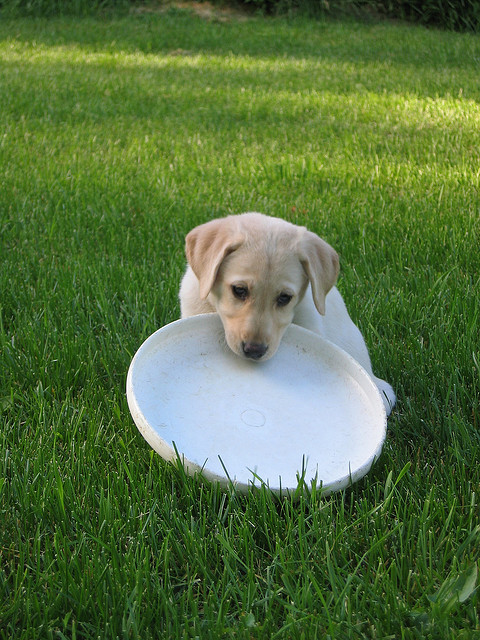What is happening in this image? In the image, a young dog, possibly a Labrador puppy, is holding a white Frisbee in its mouth. The dog appears to be in a resting position on a grassy lawn, potentially after playing or in the midst of a playful activity. What kind of mood does the image convey? The image conveys a peaceful and playful mood. The puppy's relaxed posture and the outdoor setting with the lush green grass suggest a calm yet fun atmosphere, typical of a pet enjoying playtime. 